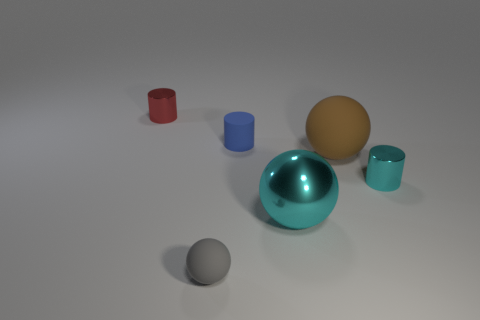There is another thing that is the same color as the large metallic thing; what is its material?
Your answer should be compact. Metal. Do the tiny metallic thing on the left side of the tiny rubber sphere and the large object that is behind the small cyan thing have the same shape?
Keep it short and to the point. No. There is a cylinder that is in front of the tiny red cylinder and on the left side of the large shiny object; what is its color?
Keep it short and to the point. Blue. There is a shiny ball; is it the same color as the tiny metal cylinder that is in front of the red shiny cylinder?
Give a very brief answer. Yes. What size is the matte thing that is on the right side of the gray sphere and in front of the tiny blue rubber cylinder?
Provide a succinct answer. Large. What number of other objects are the same color as the metal ball?
Your answer should be compact. 1. What size is the rubber sphere that is right of the cyan shiny thing in front of the small metallic cylinder that is right of the red cylinder?
Provide a short and direct response. Large. There is a blue cylinder; are there any shiny things left of it?
Provide a succinct answer. Yes. There is a gray rubber thing; is it the same size as the metal thing that is left of the cyan metal sphere?
Your answer should be very brief. Yes. What number of other things are there of the same material as the blue object
Give a very brief answer. 2. 